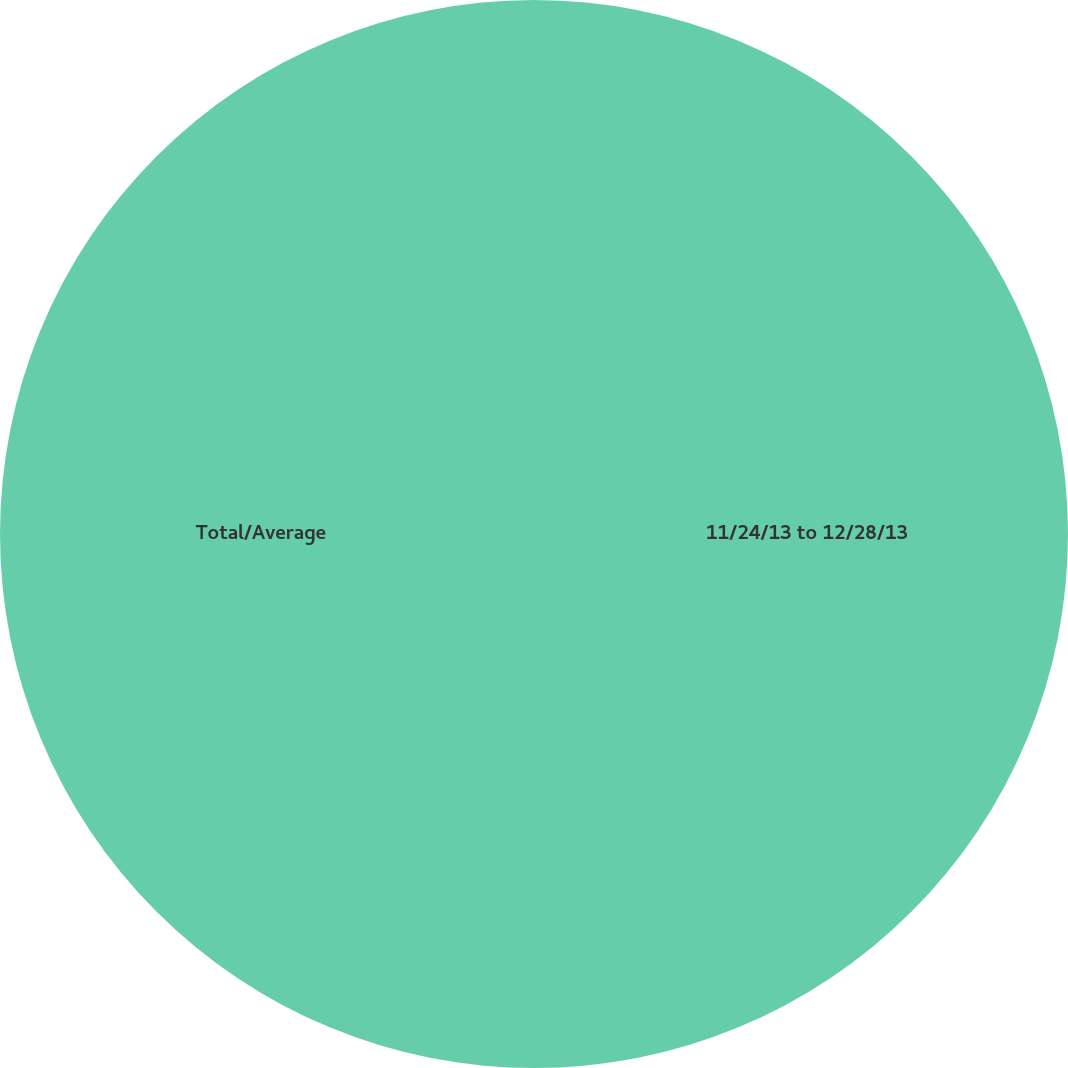Convert chart to OTSL. <chart><loc_0><loc_0><loc_500><loc_500><pie_chart><fcel>11/24/13 to 12/28/13<fcel>Total/Average<nl><fcel>50.0%<fcel>50.0%<nl></chart> 